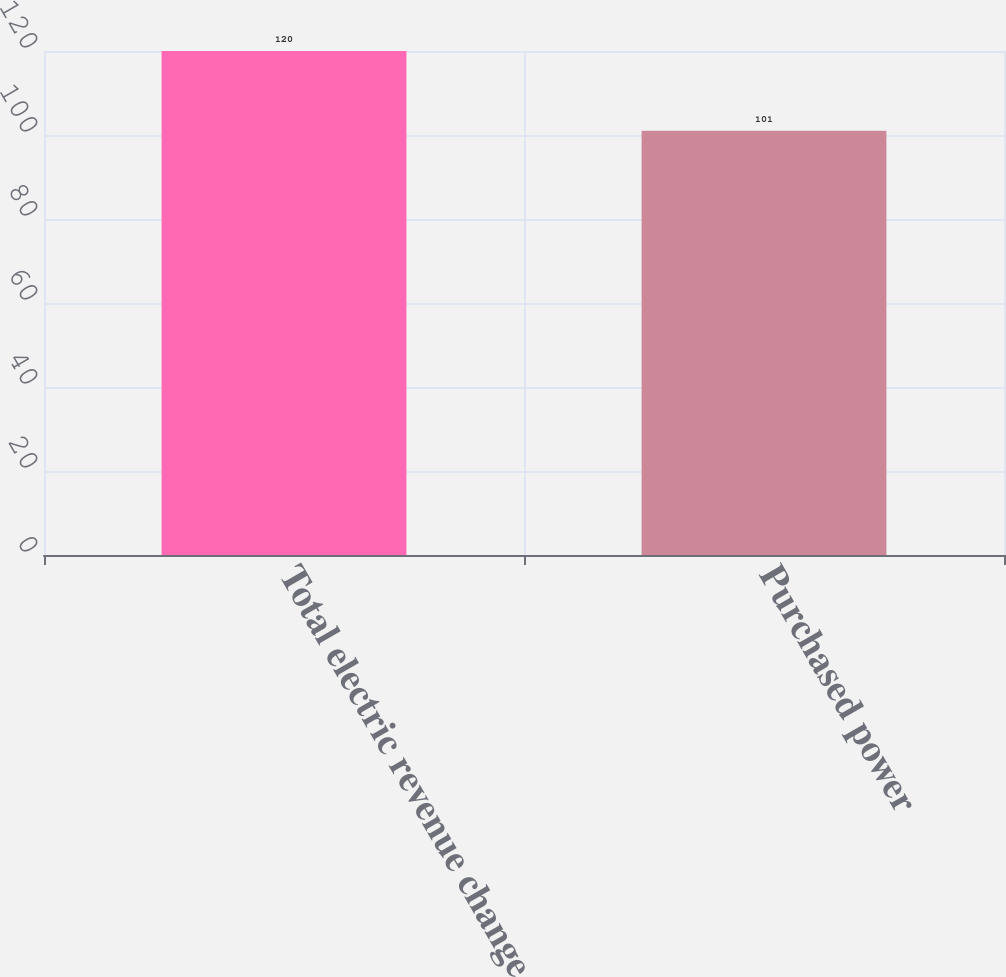Convert chart. <chart><loc_0><loc_0><loc_500><loc_500><bar_chart><fcel>Total electric revenue change<fcel>Purchased power<nl><fcel>120<fcel>101<nl></chart> 